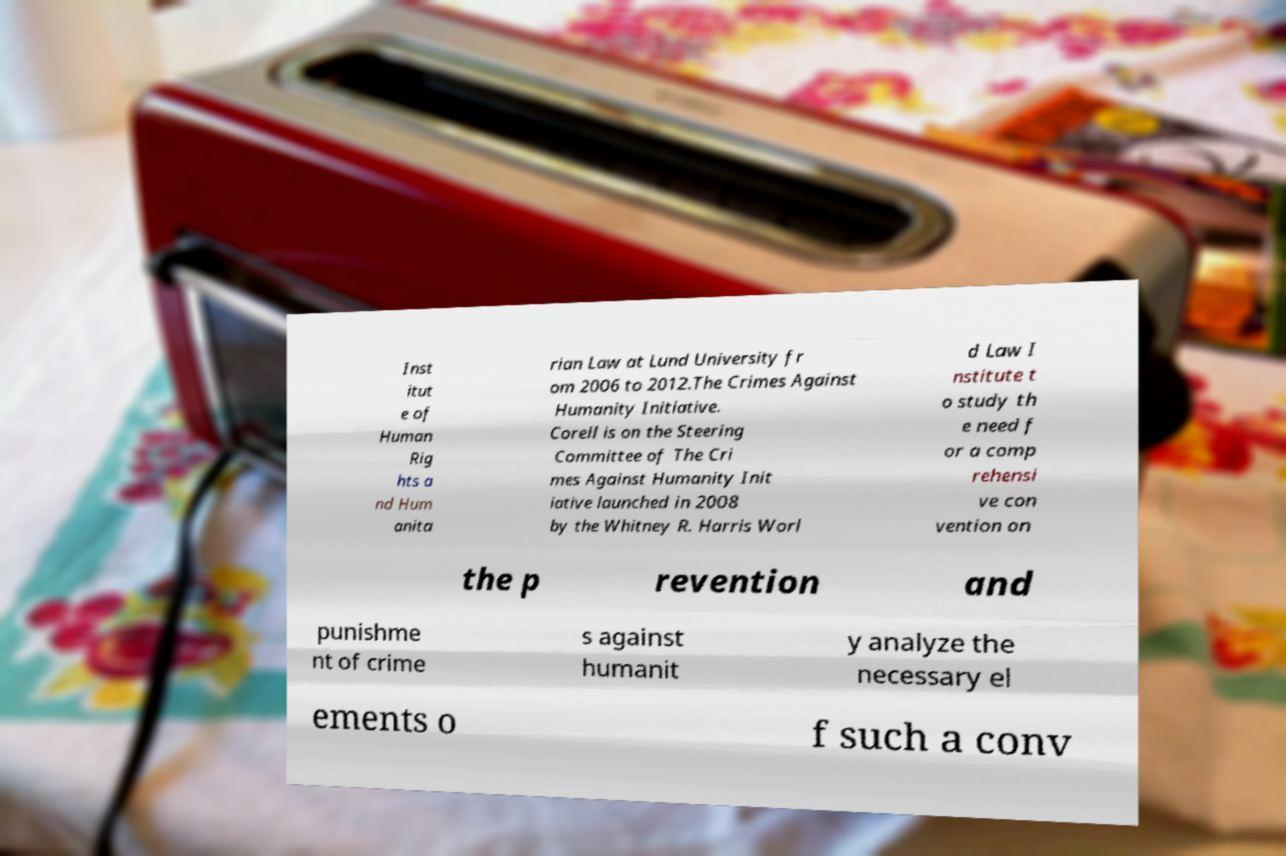Could you assist in decoding the text presented in this image and type it out clearly? Inst itut e of Human Rig hts a nd Hum anita rian Law at Lund University fr om 2006 to 2012.The Crimes Against Humanity Initiative. Corell is on the Steering Committee of The Cri mes Against Humanity Init iative launched in 2008 by the Whitney R. Harris Worl d Law I nstitute t o study th e need f or a comp rehensi ve con vention on the p revention and punishme nt of crime s against humanit y analyze the necessary el ements o f such a conv 